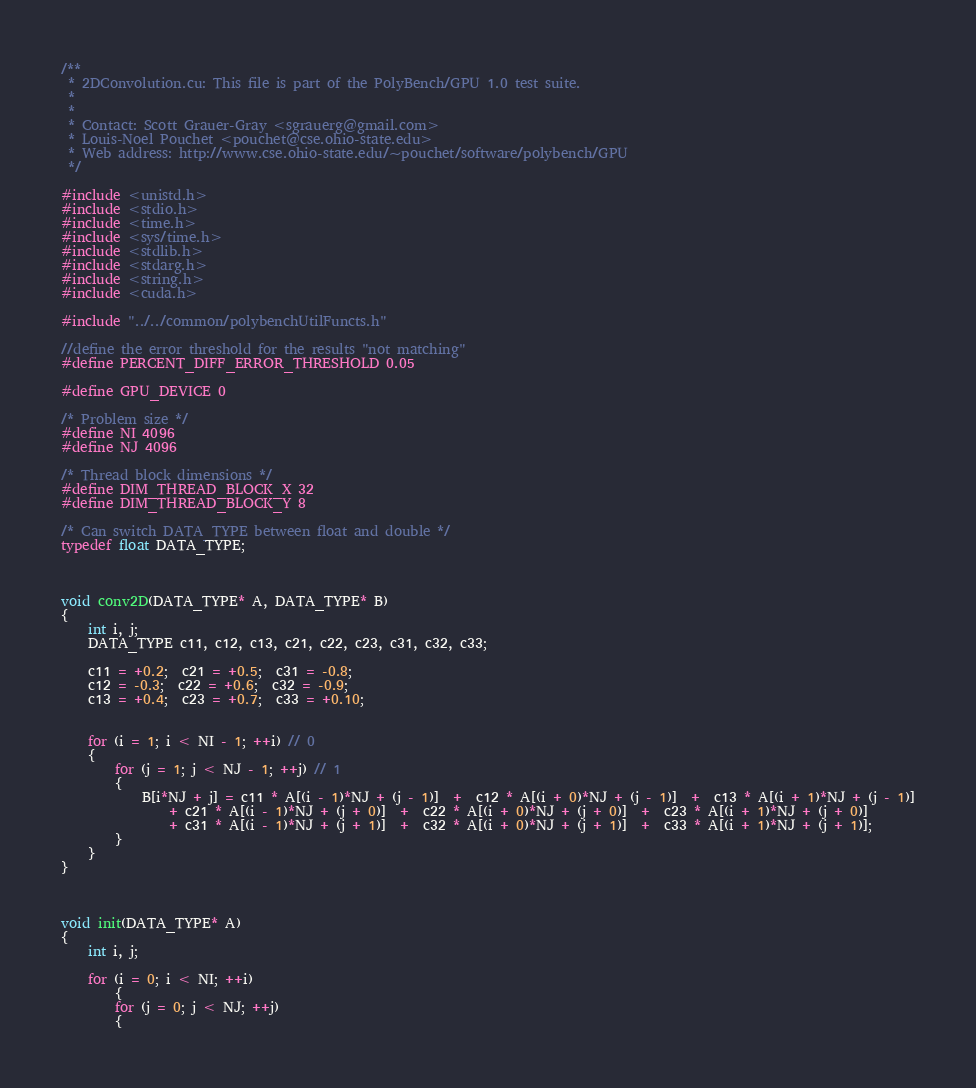<code> <loc_0><loc_0><loc_500><loc_500><_Cuda_>/**
 * 2DConvolution.cu: This file is part of the PolyBench/GPU 1.0 test suite.
 *
 *
 * Contact: Scott Grauer-Gray <sgrauerg@gmail.com>
 * Louis-Noel Pouchet <pouchet@cse.ohio-state.edu>
 * Web address: http://www.cse.ohio-state.edu/~pouchet/software/polybench/GPU
 */

#include <unistd.h>
#include <stdio.h>
#include <time.h>
#include <sys/time.h>
#include <stdlib.h>
#include <stdarg.h>
#include <string.h>
#include <cuda.h>

#include "../../common/polybenchUtilFuncts.h"

//define the error threshold for the results "not matching"
#define PERCENT_DIFF_ERROR_THRESHOLD 0.05

#define GPU_DEVICE 0

/* Problem size */
#define NI 4096
#define NJ 4096

/* Thread block dimensions */
#define DIM_THREAD_BLOCK_X 32
#define DIM_THREAD_BLOCK_Y 8

/* Can switch DATA_TYPE between float and double */
typedef float DATA_TYPE;



void conv2D(DATA_TYPE* A, DATA_TYPE* B)
{
	int i, j;
	DATA_TYPE c11, c12, c13, c21, c22, c23, c31, c32, c33;

	c11 = +0.2;  c21 = +0.5;  c31 = -0.8;
	c12 = -0.3;  c22 = +0.6;  c32 = -0.9;
	c13 = +0.4;  c23 = +0.7;  c33 = +0.10;


	for (i = 1; i < NI - 1; ++i) // 0
	{
		for (j = 1; j < NJ - 1; ++j) // 1
		{
			B[i*NJ + j] = c11 * A[(i - 1)*NJ + (j - 1)]  +  c12 * A[(i + 0)*NJ + (j - 1)]  +  c13 * A[(i + 1)*NJ + (j - 1)]
				+ c21 * A[(i - 1)*NJ + (j + 0)]  +  c22 * A[(i + 0)*NJ + (j + 0)]  +  c23 * A[(i + 1)*NJ + (j + 0)] 
				+ c31 * A[(i - 1)*NJ + (j + 1)]  +  c32 * A[(i + 0)*NJ + (j + 1)]  +  c33 * A[(i + 1)*NJ + (j + 1)];
		}
	}
}



void init(DATA_TYPE* A)
{
	int i, j;

	for (i = 0; i < NI; ++i)
    	{
		for (j = 0; j < NJ; ++j)
		{</code> 